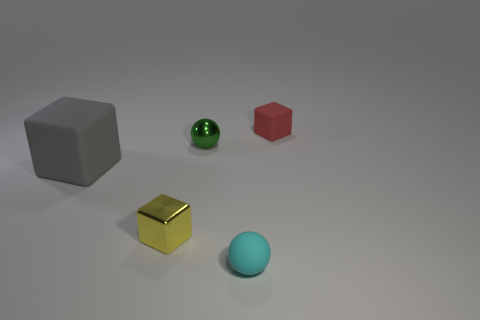Is there anything else that has the same size as the gray matte cube?
Give a very brief answer. No. There is a yellow cube that is made of the same material as the tiny green object; what size is it?
Give a very brief answer. Small. How many objects are small matte objects that are left of the tiny red object or tiny blocks behind the big gray thing?
Ensure brevity in your answer.  2. Is the number of small red objects in front of the tiny green shiny object the same as the number of red blocks that are on the right side of the small red rubber thing?
Provide a short and direct response. Yes. The small sphere that is behind the yellow object is what color?
Keep it short and to the point. Green. Is the number of tiny cubes less than the number of small yellow blocks?
Your answer should be compact. No. How many purple metal cylinders have the same size as the red matte thing?
Your answer should be very brief. 0. Are the small red object and the big thing made of the same material?
Your response must be concise. Yes. How many other big objects have the same shape as the large gray object?
Make the answer very short. 0. There is a small yellow thing that is the same material as the small green ball; what is its shape?
Keep it short and to the point. Cube. 